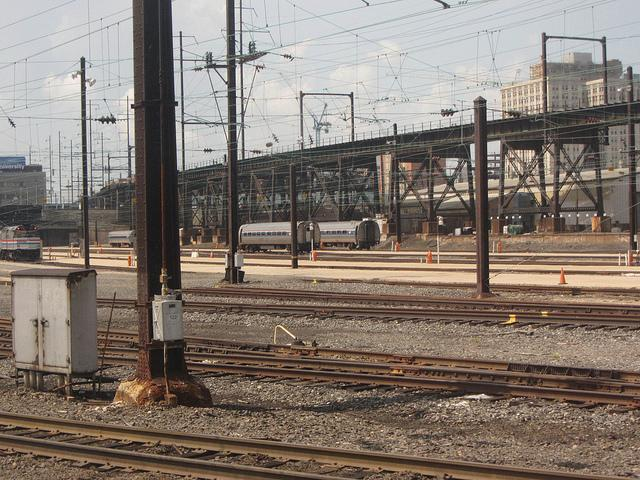What mode of transport is in the picture above? Please explain your reasoning. railway. There is both visibly trains and rails which are associated with the manner of travel in answer a. 